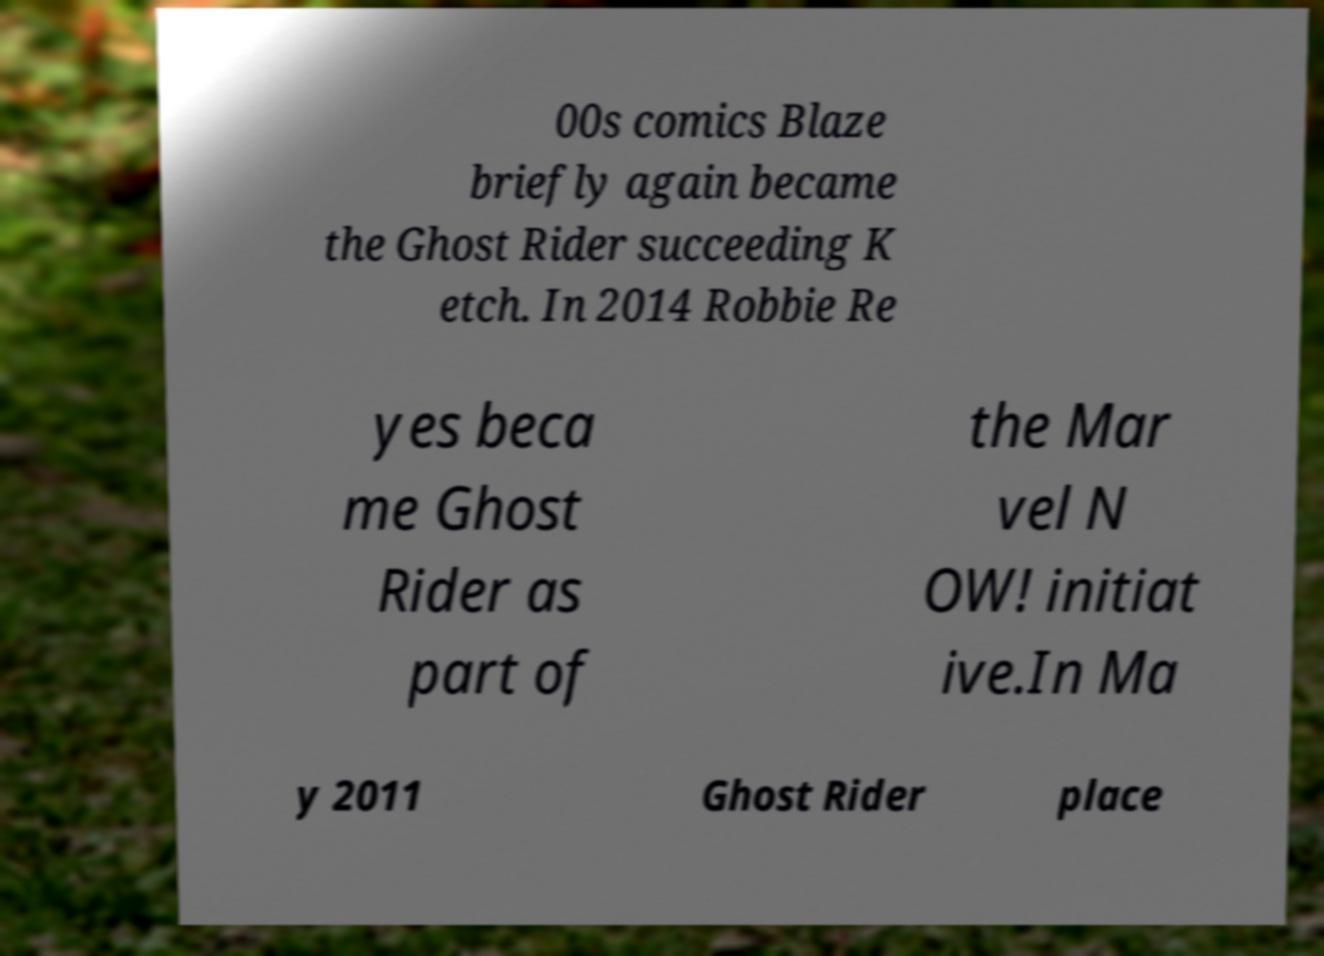Please read and relay the text visible in this image. What does it say? 00s comics Blaze briefly again became the Ghost Rider succeeding K etch. In 2014 Robbie Re yes beca me Ghost Rider as part of the Mar vel N OW! initiat ive.In Ma y 2011 Ghost Rider place 